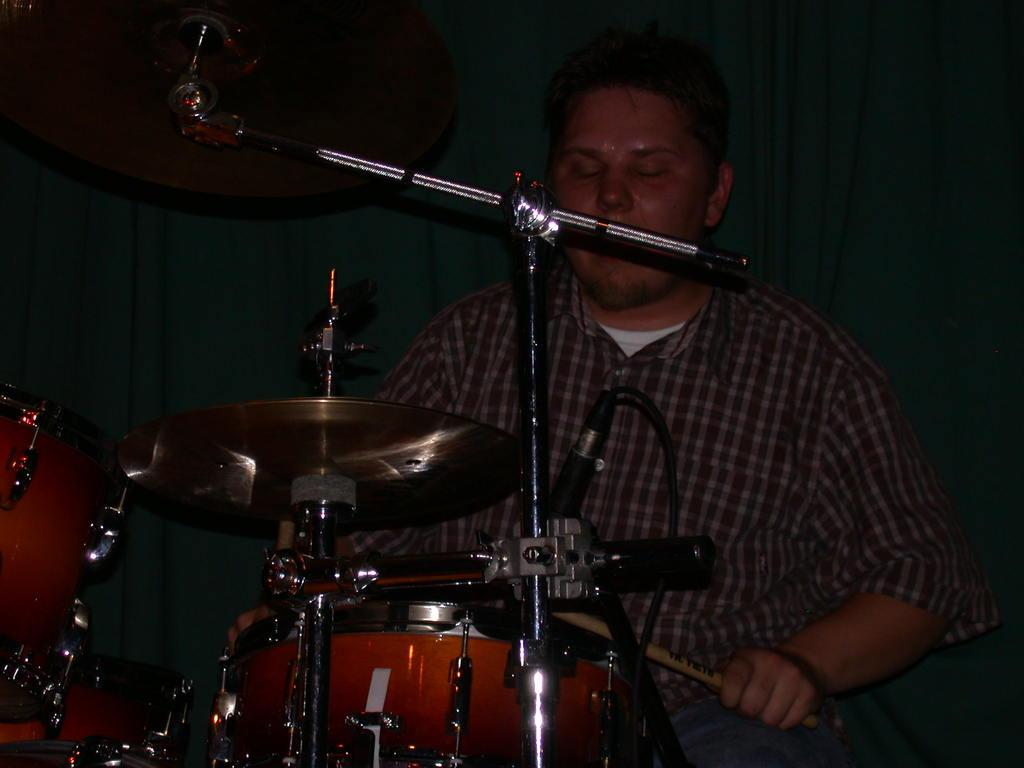What is the man in the image doing? The man is playing drums in the image. How is the man positioned in the image? The man is sitting in a chair in the image. What object is present in the image that is used for amplifying sound? There is a microphone in the image. What is the man leaning against in the image? There is a stand in the image that the man is leaning against. What can be seen in the background of the image? There is a curtain in the background of the image. What type of sea creature is visible in the image? There is no sea creature present in the image; it features a man playing drums. What is the man drinking while playing the drums in the image? There is no drink visible in the image, and the man is not shown consuming anything while playing the drums. 